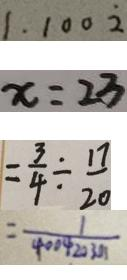Convert formula to latex. <formula><loc_0><loc_0><loc_500><loc_500>1 . 1 0 0 \dot { 2 } 
 x = 2 3 
 = \frac { 3 } { 4 } \div \frac { 1 7 } { 2 0 } 
 = \frac { 1 } { 4 0 0 4 2 0 3 0 1 }</formula> 